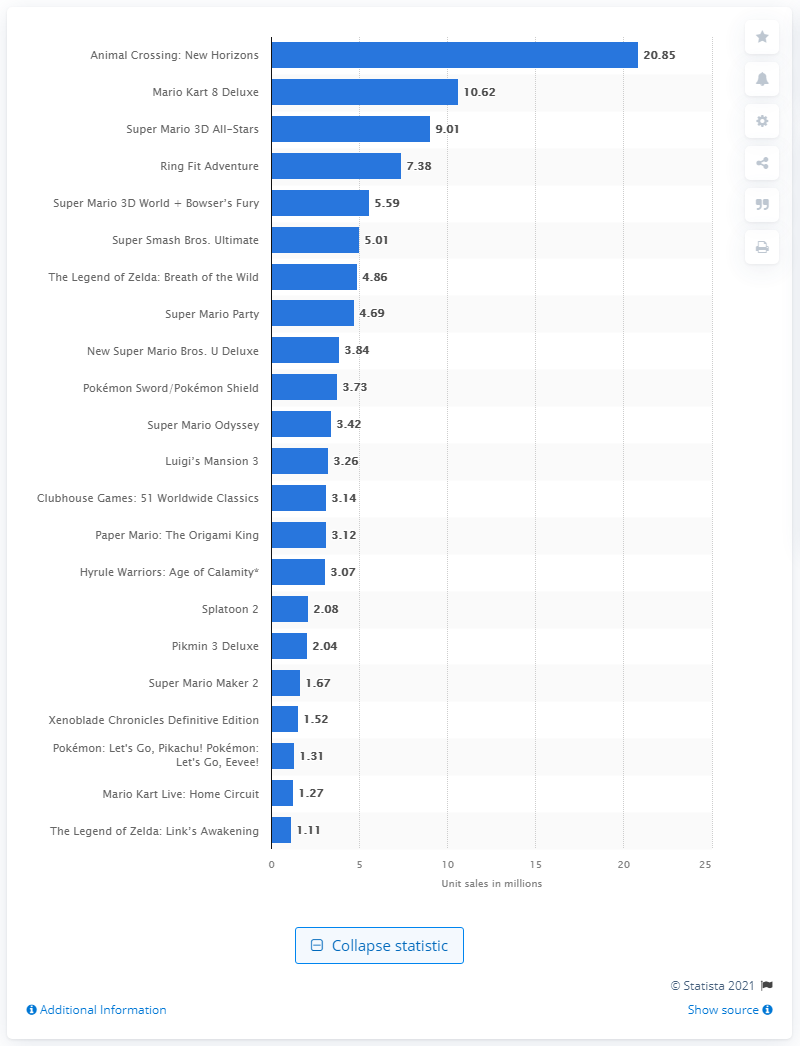Identify some key points in this picture. Mario Kart 8 Deluxe sold a global total of 10,620,000 units worldwide. Animal Crossing: New Horizons sold 20.85 million units worldwide. Nintendo's best-selling first-party title was Animal Crossing: New Horizons, which sold extremely well and became a fan favorite. 